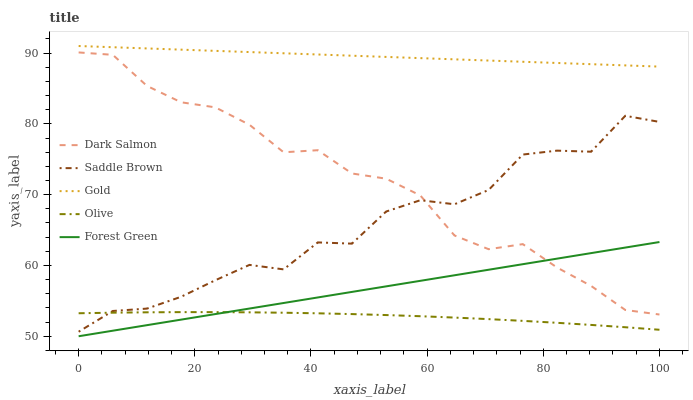Does Olive have the minimum area under the curve?
Answer yes or no. Yes. Does Gold have the maximum area under the curve?
Answer yes or no. Yes. Does Forest Green have the minimum area under the curve?
Answer yes or no. No. Does Forest Green have the maximum area under the curve?
Answer yes or no. No. Is Forest Green the smoothest?
Answer yes or no. Yes. Is Saddle Brown the roughest?
Answer yes or no. Yes. Is Dark Salmon the smoothest?
Answer yes or no. No. Is Dark Salmon the roughest?
Answer yes or no. No. Does Forest Green have the lowest value?
Answer yes or no. Yes. Does Dark Salmon have the lowest value?
Answer yes or no. No. Does Gold have the highest value?
Answer yes or no. Yes. Does Forest Green have the highest value?
Answer yes or no. No. Is Dark Salmon less than Gold?
Answer yes or no. Yes. Is Gold greater than Olive?
Answer yes or no. Yes. Does Saddle Brown intersect Dark Salmon?
Answer yes or no. Yes. Is Saddle Brown less than Dark Salmon?
Answer yes or no. No. Is Saddle Brown greater than Dark Salmon?
Answer yes or no. No. Does Dark Salmon intersect Gold?
Answer yes or no. No. 